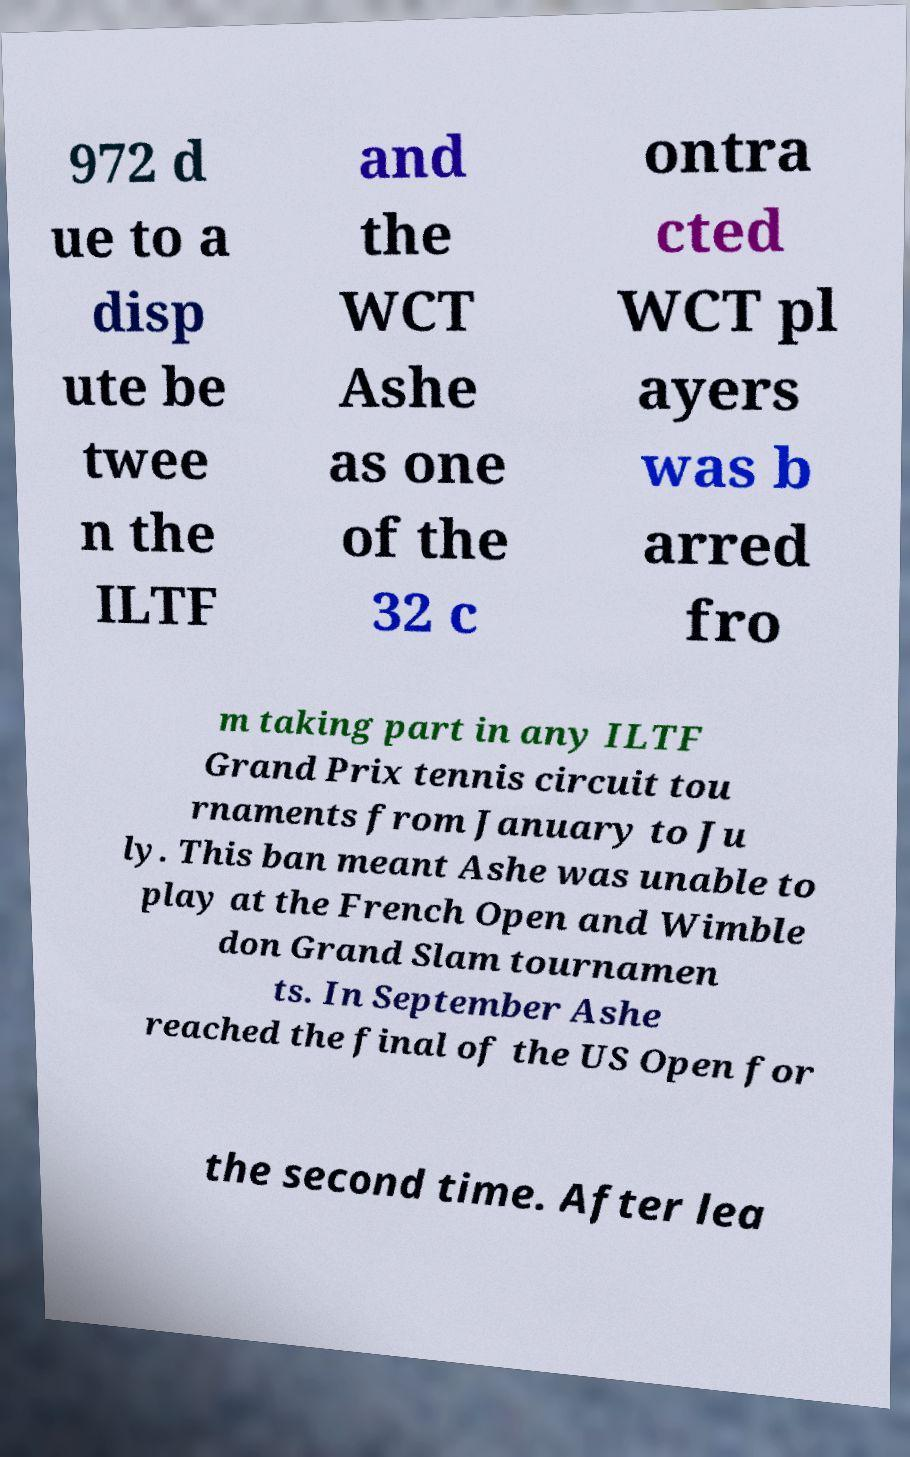For documentation purposes, I need the text within this image transcribed. Could you provide that? 972 d ue to a disp ute be twee n the ILTF and the WCT Ashe as one of the 32 c ontra cted WCT pl ayers was b arred fro m taking part in any ILTF Grand Prix tennis circuit tou rnaments from January to Ju ly. This ban meant Ashe was unable to play at the French Open and Wimble don Grand Slam tournamen ts. In September Ashe reached the final of the US Open for the second time. After lea 